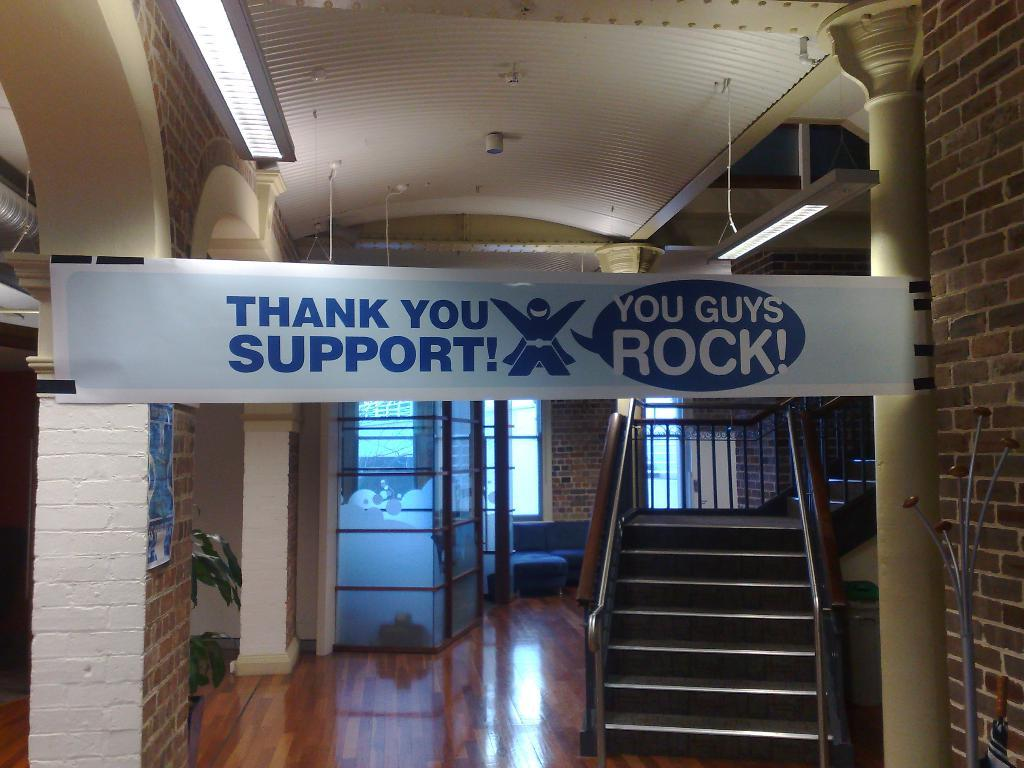Where is the setting of the image? The image is set inside a hall. What architectural feature can be seen in the hall? There are stairs in the hall. What message is conveyed by the banner in the image? The banner says "thank you" and is attached to a wall in front of the stairs. What other structural element is present in the hall? There is a pillar in the hall. What can be seen in the background of the image? There are windows visible in the background. Can you see an uncle standing next to the yak in the image? There is no uncle or yak present in the image. What type of building is the image taken in? The provided facts do not specify the type of building, only that the image is set inside a hall. 